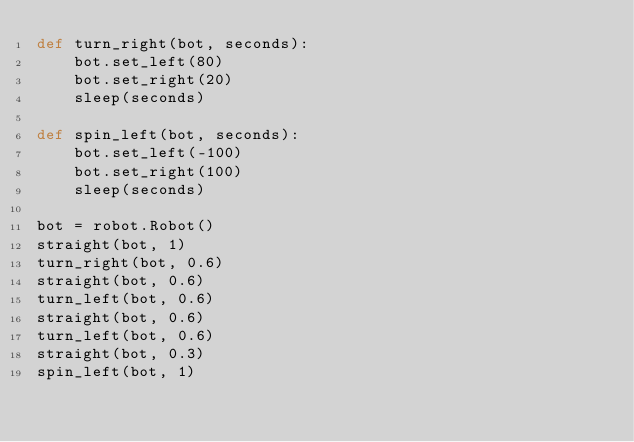<code> <loc_0><loc_0><loc_500><loc_500><_Python_>def turn_right(bot, seconds):
    bot.set_left(80)
    bot.set_right(20)
    sleep(seconds)

def spin_left(bot, seconds):
    bot.set_left(-100)
    bot.set_right(100)
    sleep(seconds)

bot = robot.Robot()
straight(bot, 1)
turn_right(bot, 0.6)
straight(bot, 0.6)
turn_left(bot, 0.6)
straight(bot, 0.6)
turn_left(bot, 0.6)
straight(bot, 0.3)
spin_left(bot, 1)

</code> 